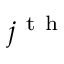Convert formula to latex. <formula><loc_0><loc_0><loc_500><loc_500>j ^ { t h }</formula> 